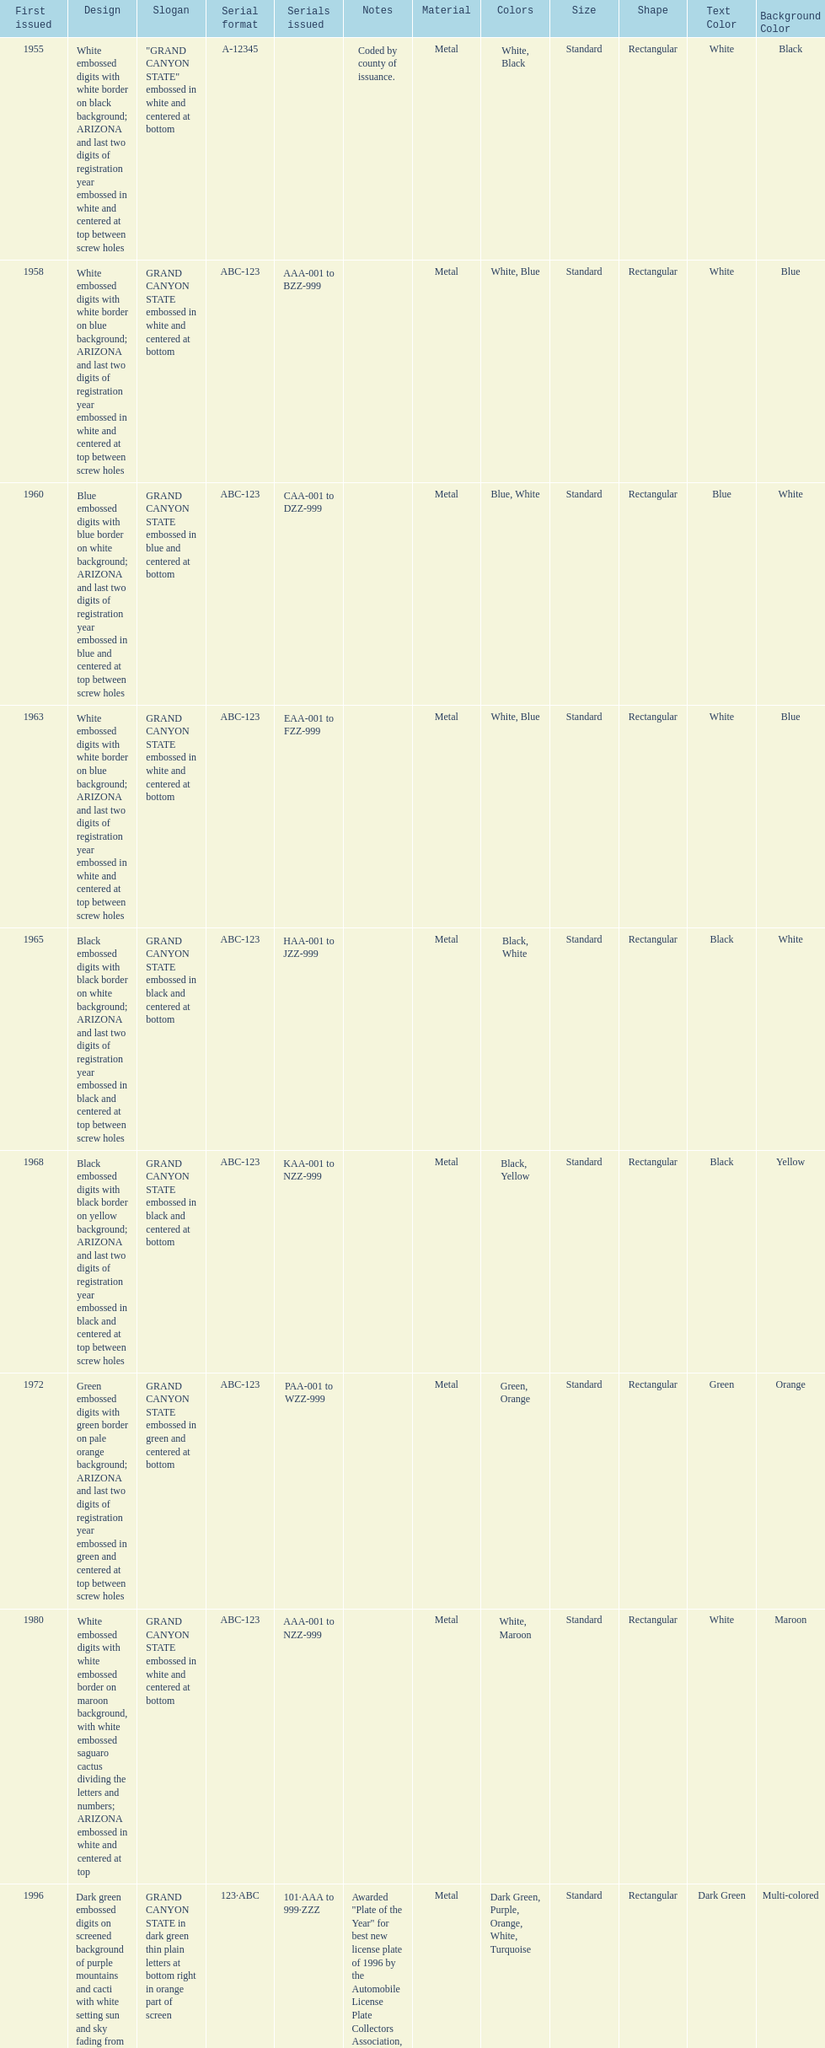Name the year of the license plate that has the largest amount of alphanumeric digits. 2008. 